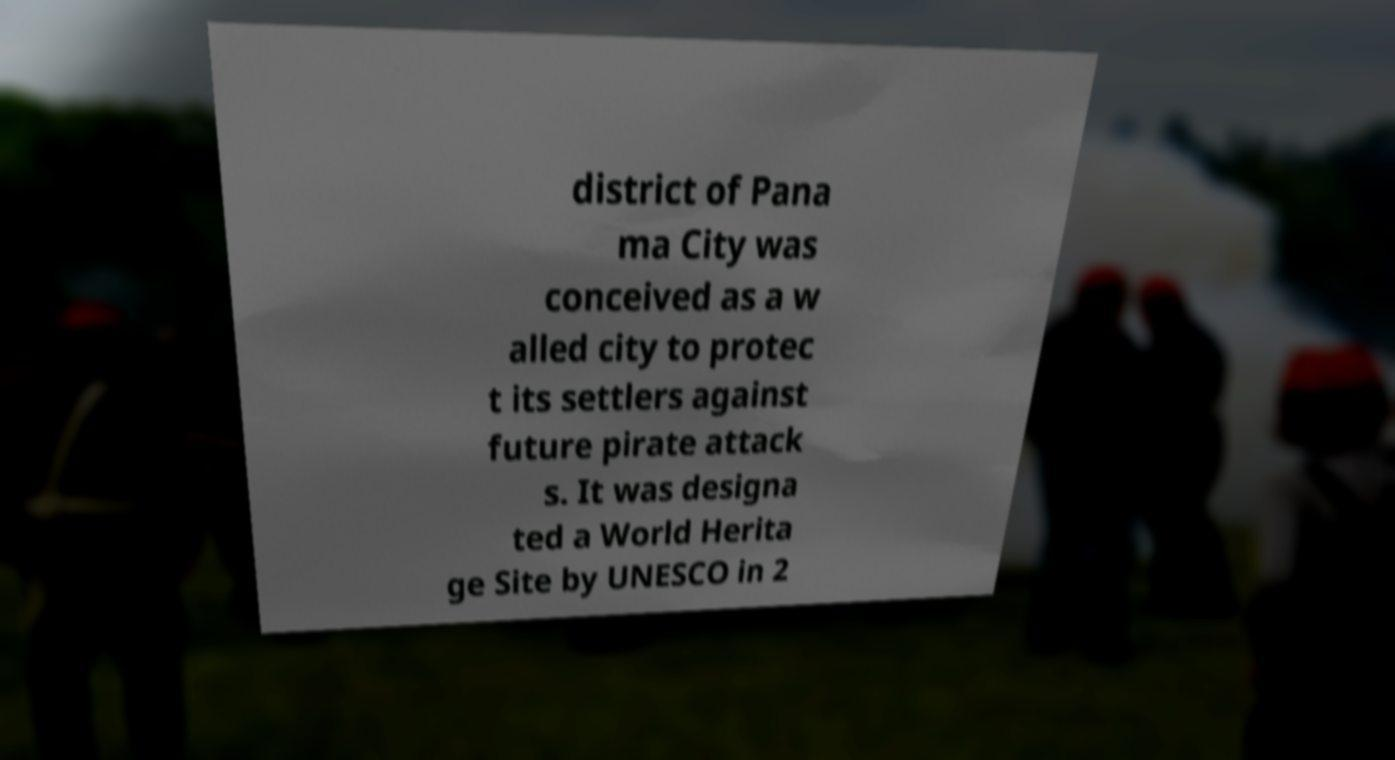Could you assist in decoding the text presented in this image and type it out clearly? district of Pana ma City was conceived as a w alled city to protec t its settlers against future pirate attack s. It was designa ted a World Herita ge Site by UNESCO in 2 